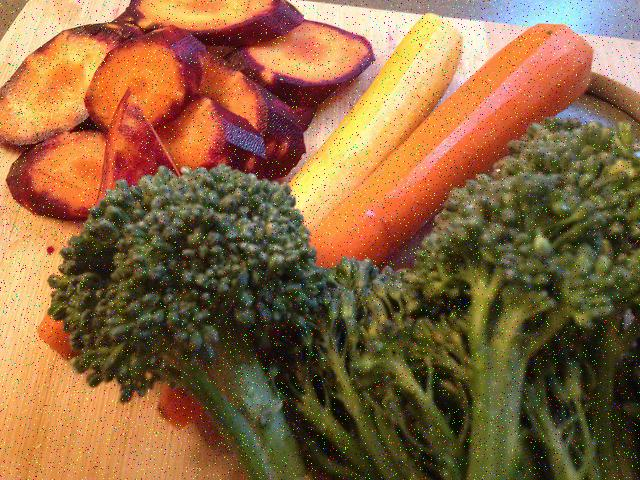How might this image appeal to the senses other than sight? One could imagine the texture of the foods depicted— the smooth firmness of the carrots, the tender succulence of the beetroots, and the crunchy florets of broccoli. Along with the textures, one might anticipate the earthy sweetness of the beets, the distinctive freshness of the carrots, and the subtle, slightly bitter taste of the broccoli, all combining to offer a tantalizing sensory experience. 